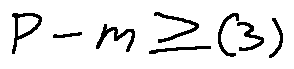<formula> <loc_0><loc_0><loc_500><loc_500>P - m \geq ( 3 )</formula> 